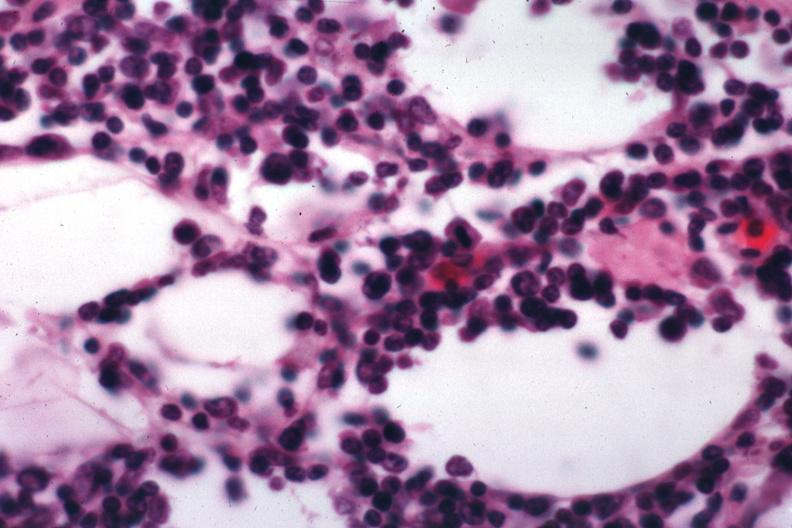s lymph node present?
Answer the question using a single word or phrase. Yes 